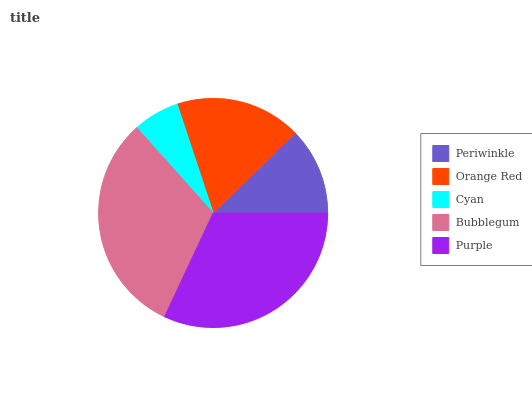Is Cyan the minimum?
Answer yes or no. Yes. Is Purple the maximum?
Answer yes or no. Yes. Is Orange Red the minimum?
Answer yes or no. No. Is Orange Red the maximum?
Answer yes or no. No. Is Orange Red greater than Periwinkle?
Answer yes or no. Yes. Is Periwinkle less than Orange Red?
Answer yes or no. Yes. Is Periwinkle greater than Orange Red?
Answer yes or no. No. Is Orange Red less than Periwinkle?
Answer yes or no. No. Is Orange Red the high median?
Answer yes or no. Yes. Is Orange Red the low median?
Answer yes or no. Yes. Is Bubblegum the high median?
Answer yes or no. No. Is Cyan the low median?
Answer yes or no. No. 